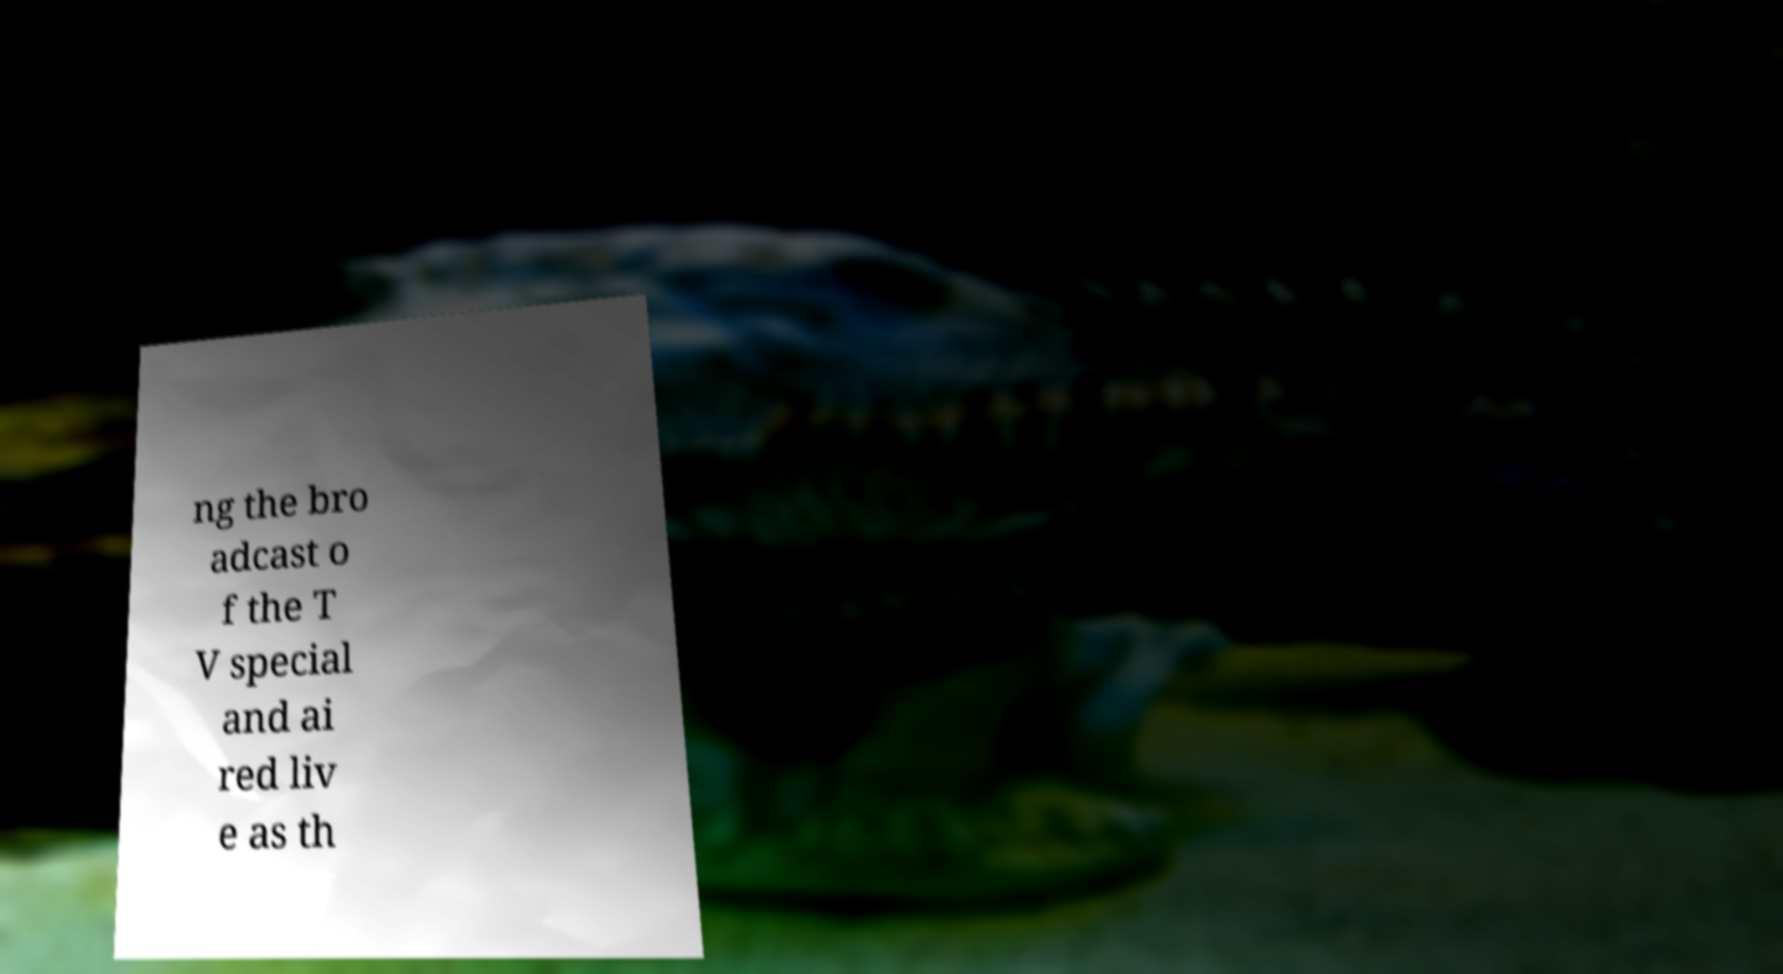Can you accurately transcribe the text from the provided image for me? ng the bro adcast o f the T V special and ai red liv e as th 